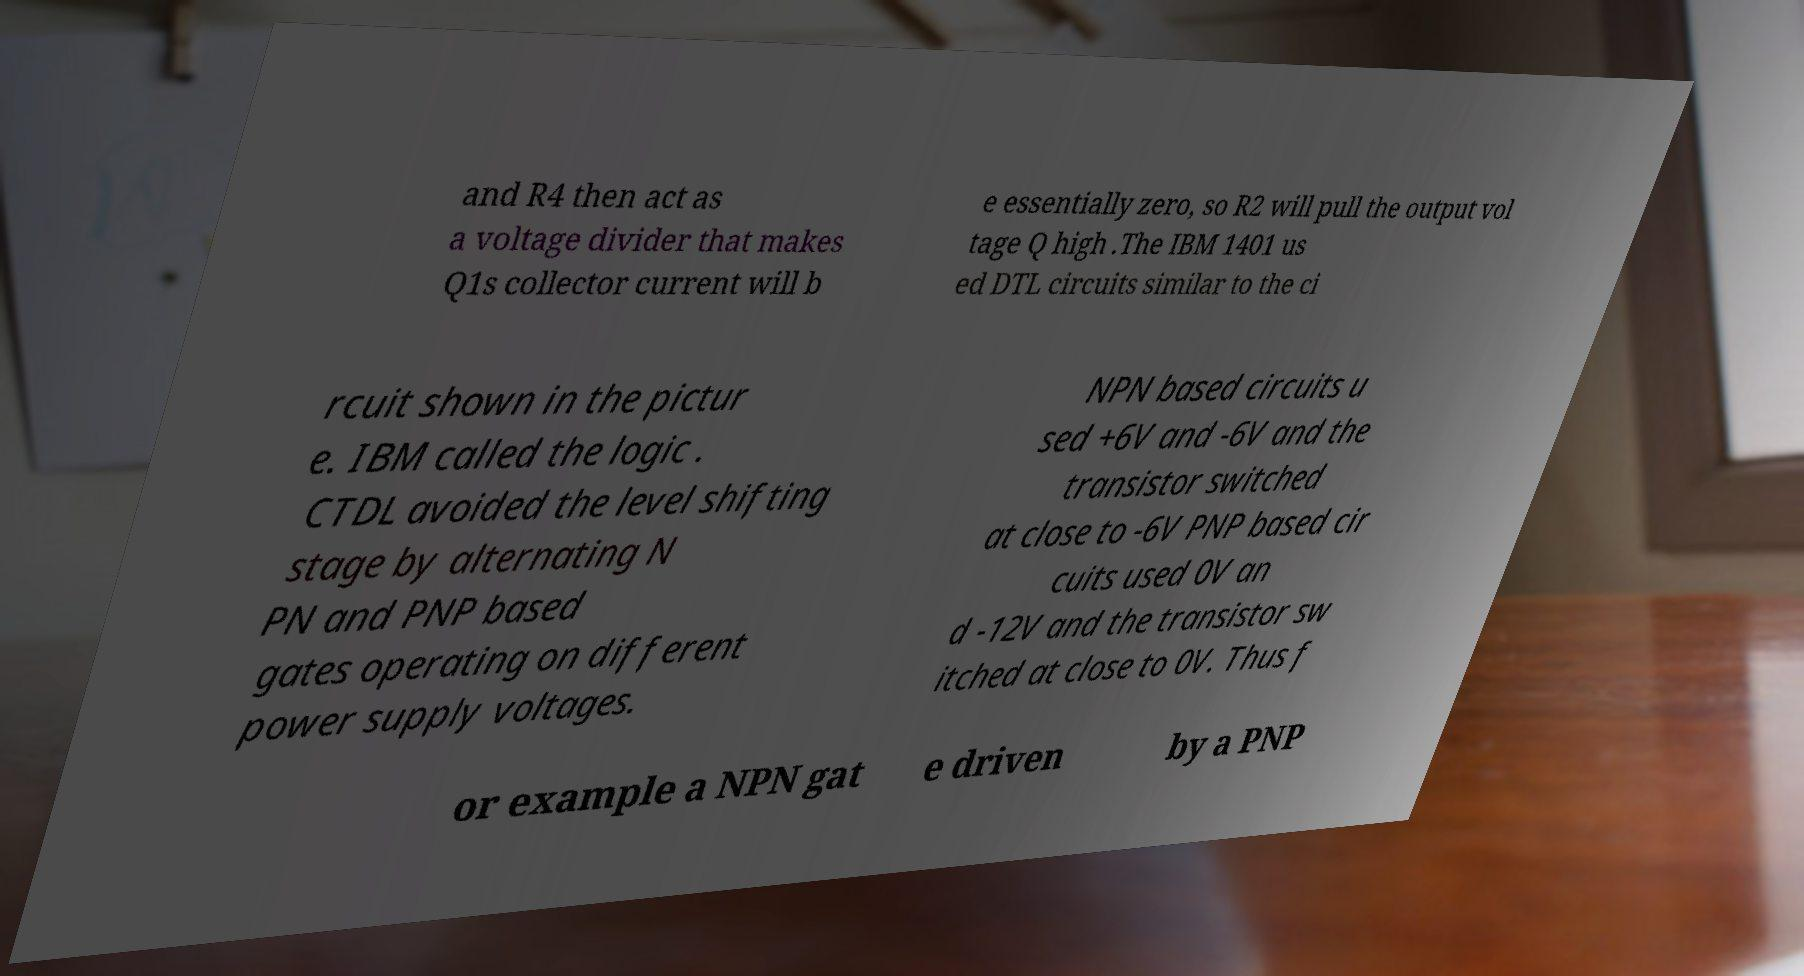What messages or text are displayed in this image? I need them in a readable, typed format. and R4 then act as a voltage divider that makes Q1s collector current will b e essentially zero, so R2 will pull the output vol tage Q high .The IBM 1401 us ed DTL circuits similar to the ci rcuit shown in the pictur e. IBM called the logic . CTDL avoided the level shifting stage by alternating N PN and PNP based gates operating on different power supply voltages. NPN based circuits u sed +6V and -6V and the transistor switched at close to -6V PNP based cir cuits used 0V an d -12V and the transistor sw itched at close to 0V. Thus f or example a NPN gat e driven by a PNP 